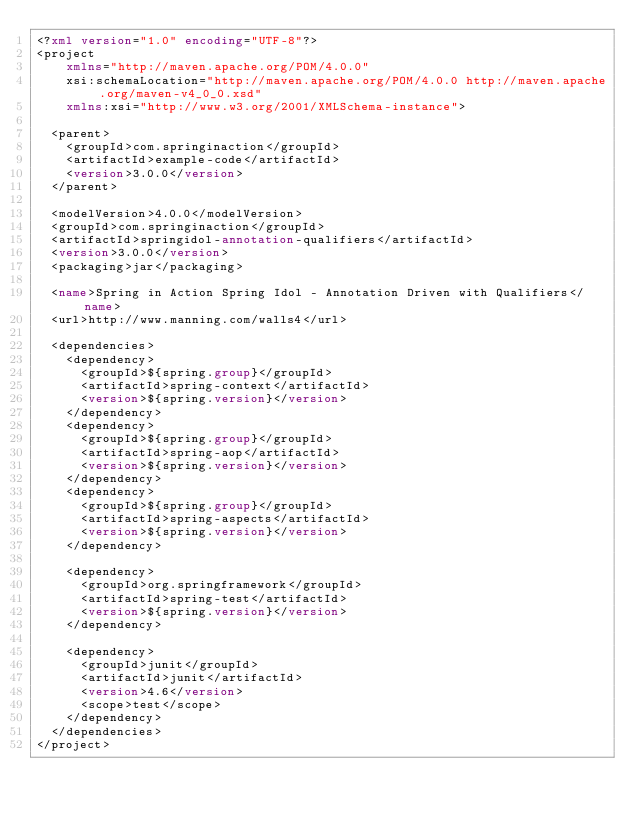<code> <loc_0><loc_0><loc_500><loc_500><_XML_><?xml version="1.0" encoding="UTF-8"?>
<project
    xmlns="http://maven.apache.org/POM/4.0.0"
    xsi:schemaLocation="http://maven.apache.org/POM/4.0.0 http://maven.apache.org/maven-v4_0_0.xsd"
    xmlns:xsi="http://www.w3.org/2001/XMLSchema-instance">

  <parent>
    <groupId>com.springinaction</groupId>
    <artifactId>example-code</artifactId>
    <version>3.0.0</version>
  </parent>

  <modelVersion>4.0.0</modelVersion>
  <groupId>com.springinaction</groupId>
  <artifactId>springidol-annotation-qualifiers</artifactId>
  <version>3.0.0</version>
  <packaging>jar</packaging>
  
  <name>Spring in Action Spring Idol - Annotation Driven with Qualifiers</name>
  <url>http://www.manning.com/walls4</url>

  <dependencies>
    <dependency>
      <groupId>${spring.group}</groupId>
      <artifactId>spring-context</artifactId>
      <version>${spring.version}</version>
    </dependency>
    <dependency>
      <groupId>${spring.group}</groupId>
      <artifactId>spring-aop</artifactId>
      <version>${spring.version}</version>
    </dependency>
    <dependency>
      <groupId>${spring.group}</groupId>
      <artifactId>spring-aspects</artifactId>
      <version>${spring.version}</version>
    </dependency>

    <dependency>
      <groupId>org.springframework</groupId>
      <artifactId>spring-test</artifactId>
      <version>${spring.version}</version>
    </dependency>
    
    <dependency>
      <groupId>junit</groupId>
      <artifactId>junit</artifactId>
      <version>4.6</version>
      <scope>test</scope>
    </dependency>
  </dependencies>
</project></code> 